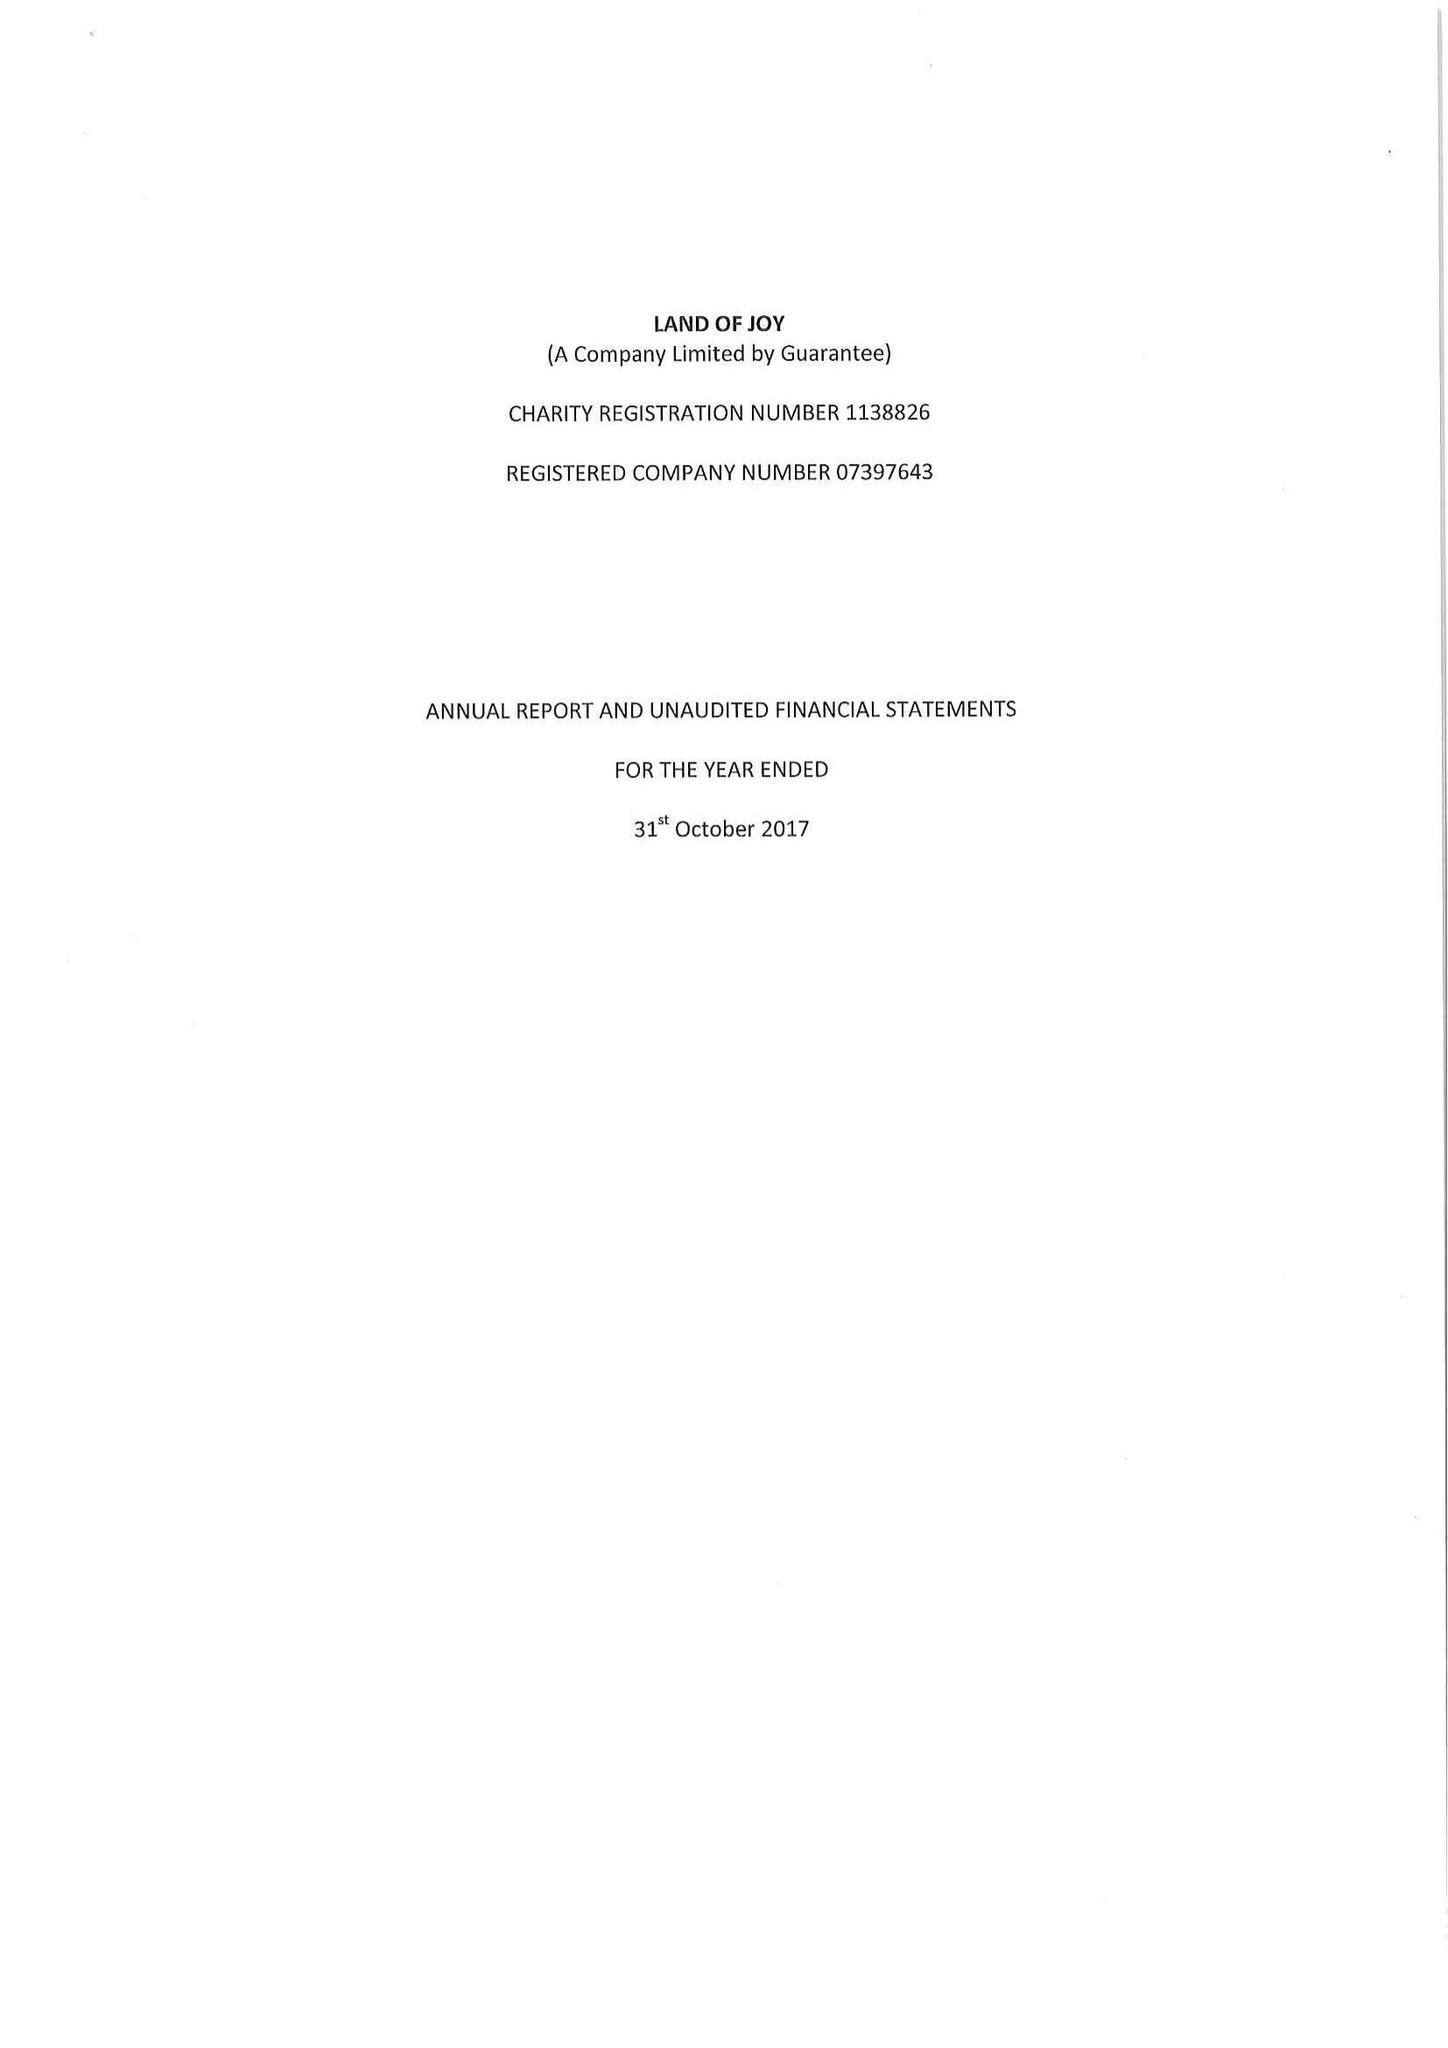What is the value for the income_annually_in_british_pounds?
Answer the question using a single word or phrase. 156761.00 